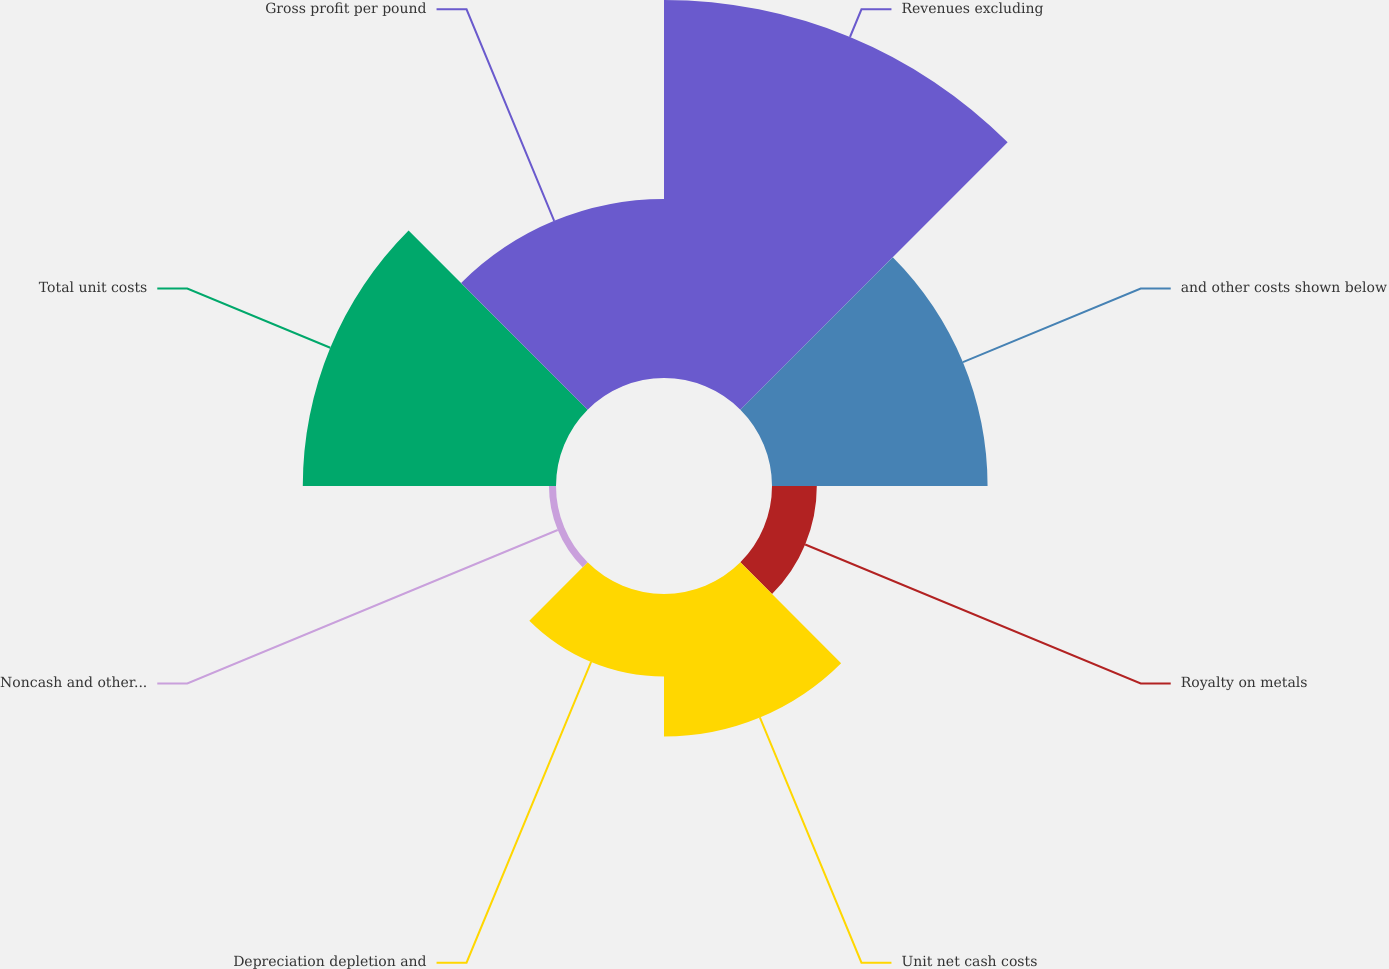Convert chart. <chart><loc_0><loc_0><loc_500><loc_500><pie_chart><fcel>Revenues excluding<fcel>and other costs shown below<fcel>Royalty on metals<fcel>Unit net cash costs<fcel>Depreciation depletion and<fcel>Noncash and other costs net<fcel>Total unit costs<fcel>Gross profit per pound<nl><fcel>29.02%<fcel>16.55%<fcel>3.44%<fcel>10.94%<fcel>6.33%<fcel>0.54%<fcel>19.44%<fcel>13.74%<nl></chart> 